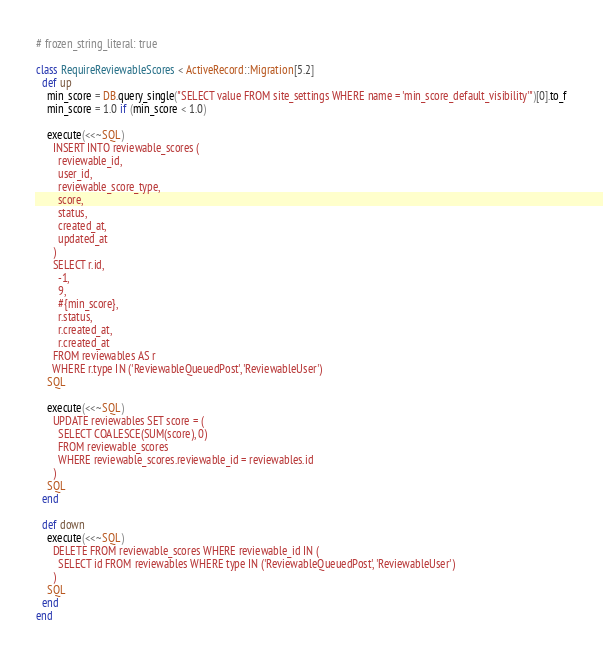Convert code to text. <code><loc_0><loc_0><loc_500><loc_500><_Ruby_># frozen_string_literal: true

class RequireReviewableScores < ActiveRecord::Migration[5.2]
  def up
    min_score = DB.query_single("SELECT value FROM site_settings WHERE name = 'min_score_default_visibility'")[0].to_f
    min_score = 1.0 if (min_score < 1.0)

    execute(<<~SQL)
      INSERT INTO reviewable_scores (
        reviewable_id,
        user_id,
        reviewable_score_type,
        score,
        status,
        created_at,
        updated_at
      )
      SELECT r.id,
        -1,
        9,
        #{min_score},
        r.status,
        r.created_at,
        r.created_at
      FROM reviewables AS r
      WHERE r.type IN ('ReviewableQueuedPost', 'ReviewableUser')
    SQL

    execute(<<~SQL)
      UPDATE reviewables SET score = (
        SELECT COALESCE(SUM(score), 0)
        FROM reviewable_scores
        WHERE reviewable_scores.reviewable_id = reviewables.id
      )
    SQL
  end

  def down
    execute(<<~SQL)
      DELETE FROM reviewable_scores WHERE reviewable_id IN (
        SELECT id FROM reviewables WHERE type IN ('ReviewableQueuedPost', 'ReviewableUser')
      )
    SQL
  end
end
</code> 